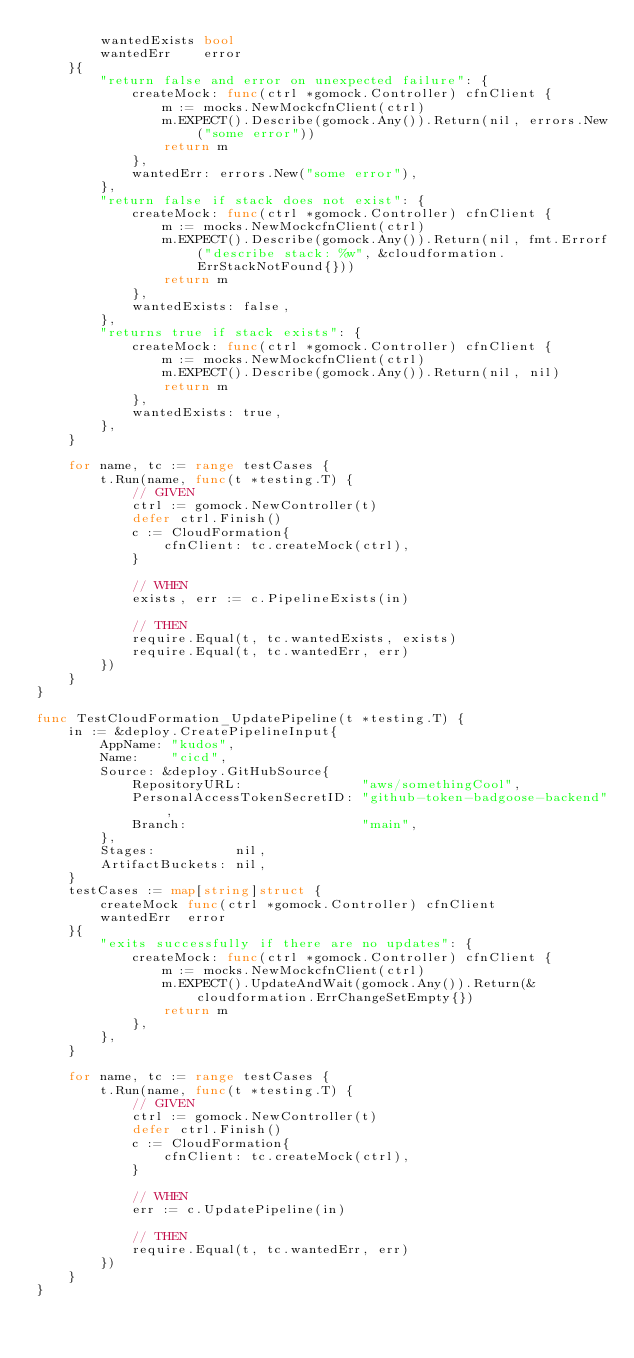<code> <loc_0><loc_0><loc_500><loc_500><_Go_>		wantedExists bool
		wantedErr    error
	}{
		"return false and error on unexpected failure": {
			createMock: func(ctrl *gomock.Controller) cfnClient {
				m := mocks.NewMockcfnClient(ctrl)
				m.EXPECT().Describe(gomock.Any()).Return(nil, errors.New("some error"))
				return m
			},
			wantedErr: errors.New("some error"),
		},
		"return false if stack does not exist": {
			createMock: func(ctrl *gomock.Controller) cfnClient {
				m := mocks.NewMockcfnClient(ctrl)
				m.EXPECT().Describe(gomock.Any()).Return(nil, fmt.Errorf("describe stack: %w", &cloudformation.ErrStackNotFound{}))
				return m
			},
			wantedExists: false,
		},
		"returns true if stack exists": {
			createMock: func(ctrl *gomock.Controller) cfnClient {
				m := mocks.NewMockcfnClient(ctrl)
				m.EXPECT().Describe(gomock.Any()).Return(nil, nil)
				return m
			},
			wantedExists: true,
		},
	}

	for name, tc := range testCases {
		t.Run(name, func(t *testing.T) {
			// GIVEN
			ctrl := gomock.NewController(t)
			defer ctrl.Finish()
			c := CloudFormation{
				cfnClient: tc.createMock(ctrl),
			}

			// WHEN
			exists, err := c.PipelineExists(in)

			// THEN
			require.Equal(t, tc.wantedExists, exists)
			require.Equal(t, tc.wantedErr, err)
		})
	}
}

func TestCloudFormation_UpdatePipeline(t *testing.T) {
	in := &deploy.CreatePipelineInput{
		AppName: "kudos",
		Name:    "cicd",
		Source: &deploy.GitHubSource{
			RepositoryURL:               "aws/somethingCool",
			PersonalAccessTokenSecretID: "github-token-badgoose-backend",
			Branch:                      "main",
		},
		Stages:          nil,
		ArtifactBuckets: nil,
	}
	testCases := map[string]struct {
		createMock func(ctrl *gomock.Controller) cfnClient
		wantedErr  error
	}{
		"exits successfully if there are no updates": {
			createMock: func(ctrl *gomock.Controller) cfnClient {
				m := mocks.NewMockcfnClient(ctrl)
				m.EXPECT().UpdateAndWait(gomock.Any()).Return(&cloudformation.ErrChangeSetEmpty{})
				return m
			},
		},
	}

	for name, tc := range testCases {
		t.Run(name, func(t *testing.T) {
			// GIVEN
			ctrl := gomock.NewController(t)
			defer ctrl.Finish()
			c := CloudFormation{
				cfnClient: tc.createMock(ctrl),
			}

			// WHEN
			err := c.UpdatePipeline(in)

			// THEN
			require.Equal(t, tc.wantedErr, err)
		})
	}
}
</code> 